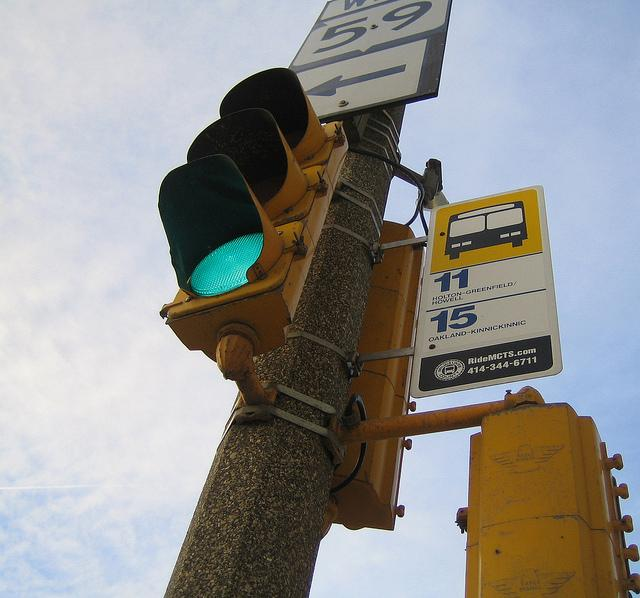What is the largest of the blue numbers on the sign?

Choices:
A) 98
B) 15
C) 77
D) 12 15 